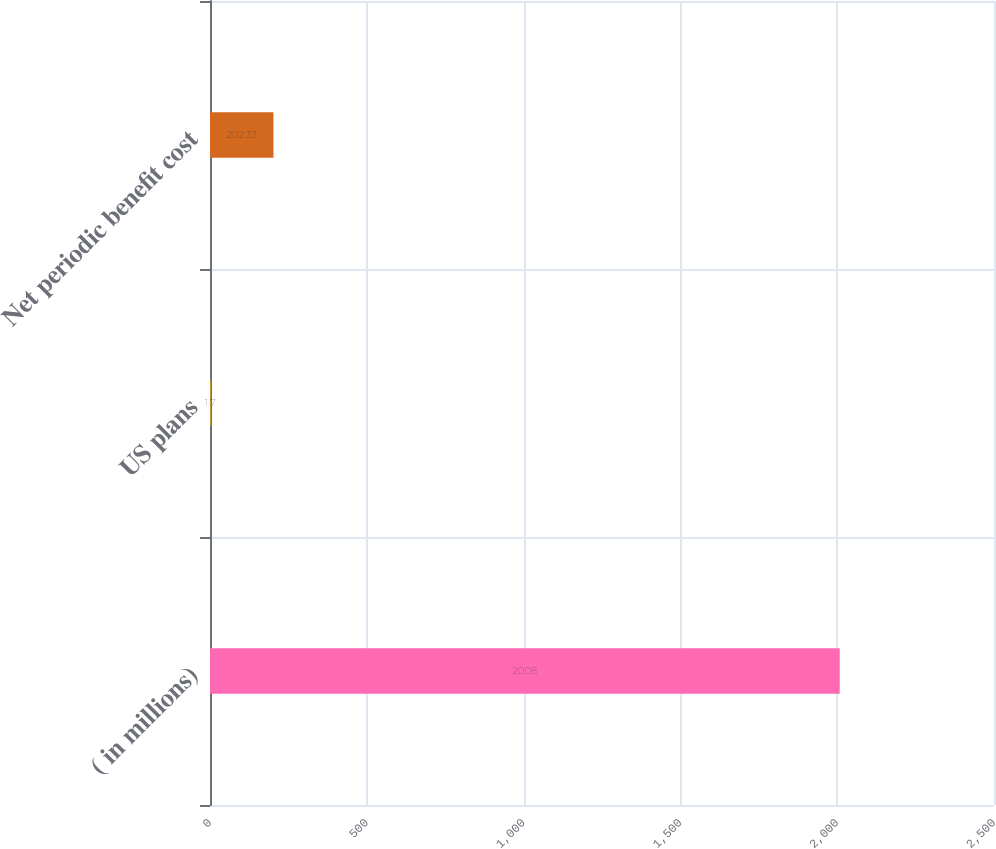Convert chart to OTSL. <chart><loc_0><loc_0><loc_500><loc_500><bar_chart><fcel>( in millions)<fcel>US plans<fcel>Net periodic benefit cost<nl><fcel>2008<fcel>1.7<fcel>202.33<nl></chart> 